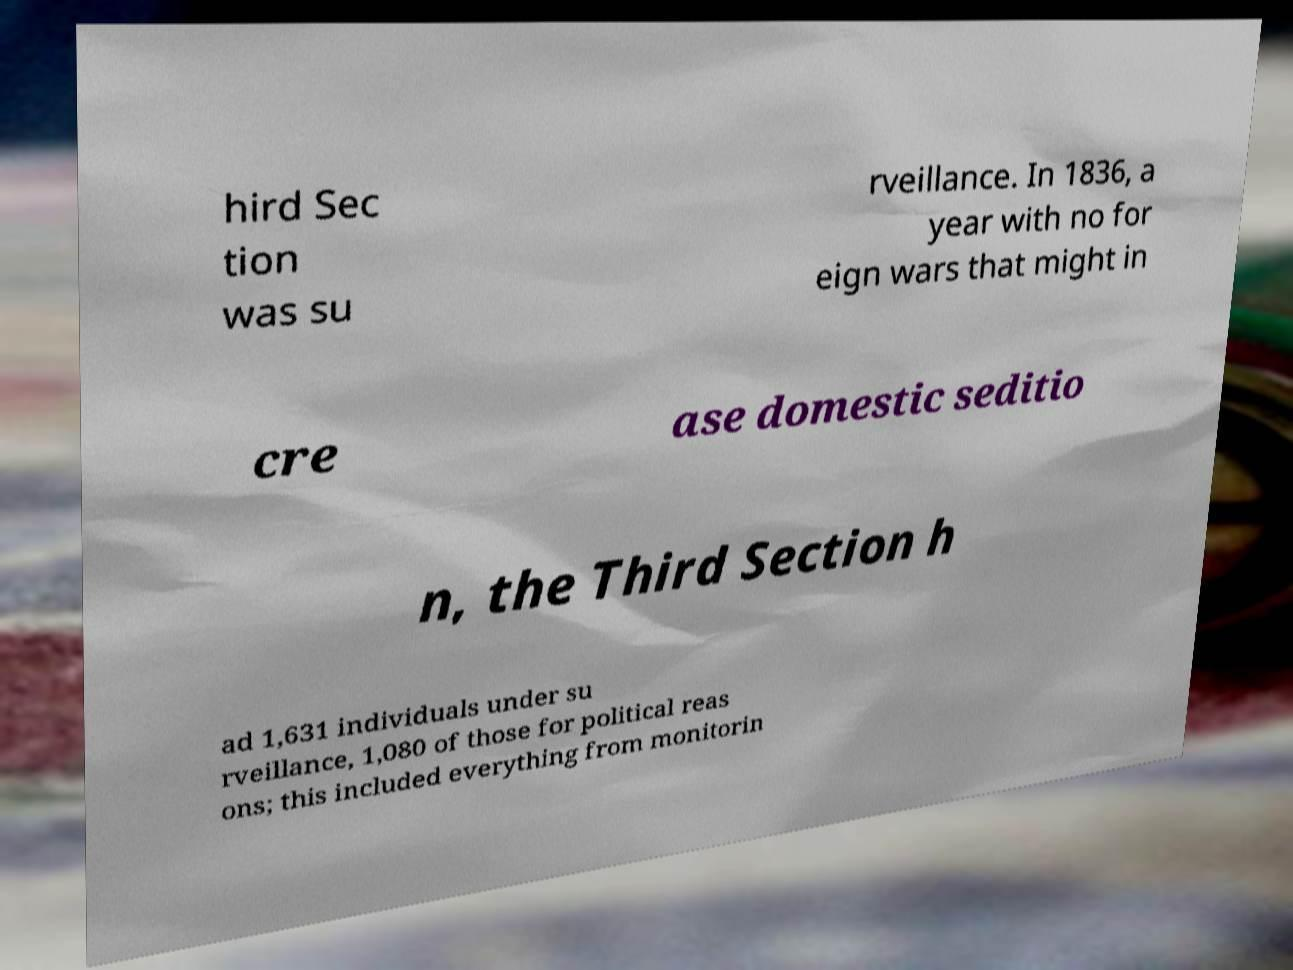What messages or text are displayed in this image? I need them in a readable, typed format. hird Sec tion was su rveillance. In 1836, a year with no for eign wars that might in cre ase domestic seditio n, the Third Section h ad 1,631 individuals under su rveillance, 1,080 of those for political reas ons; this included everything from monitorin 